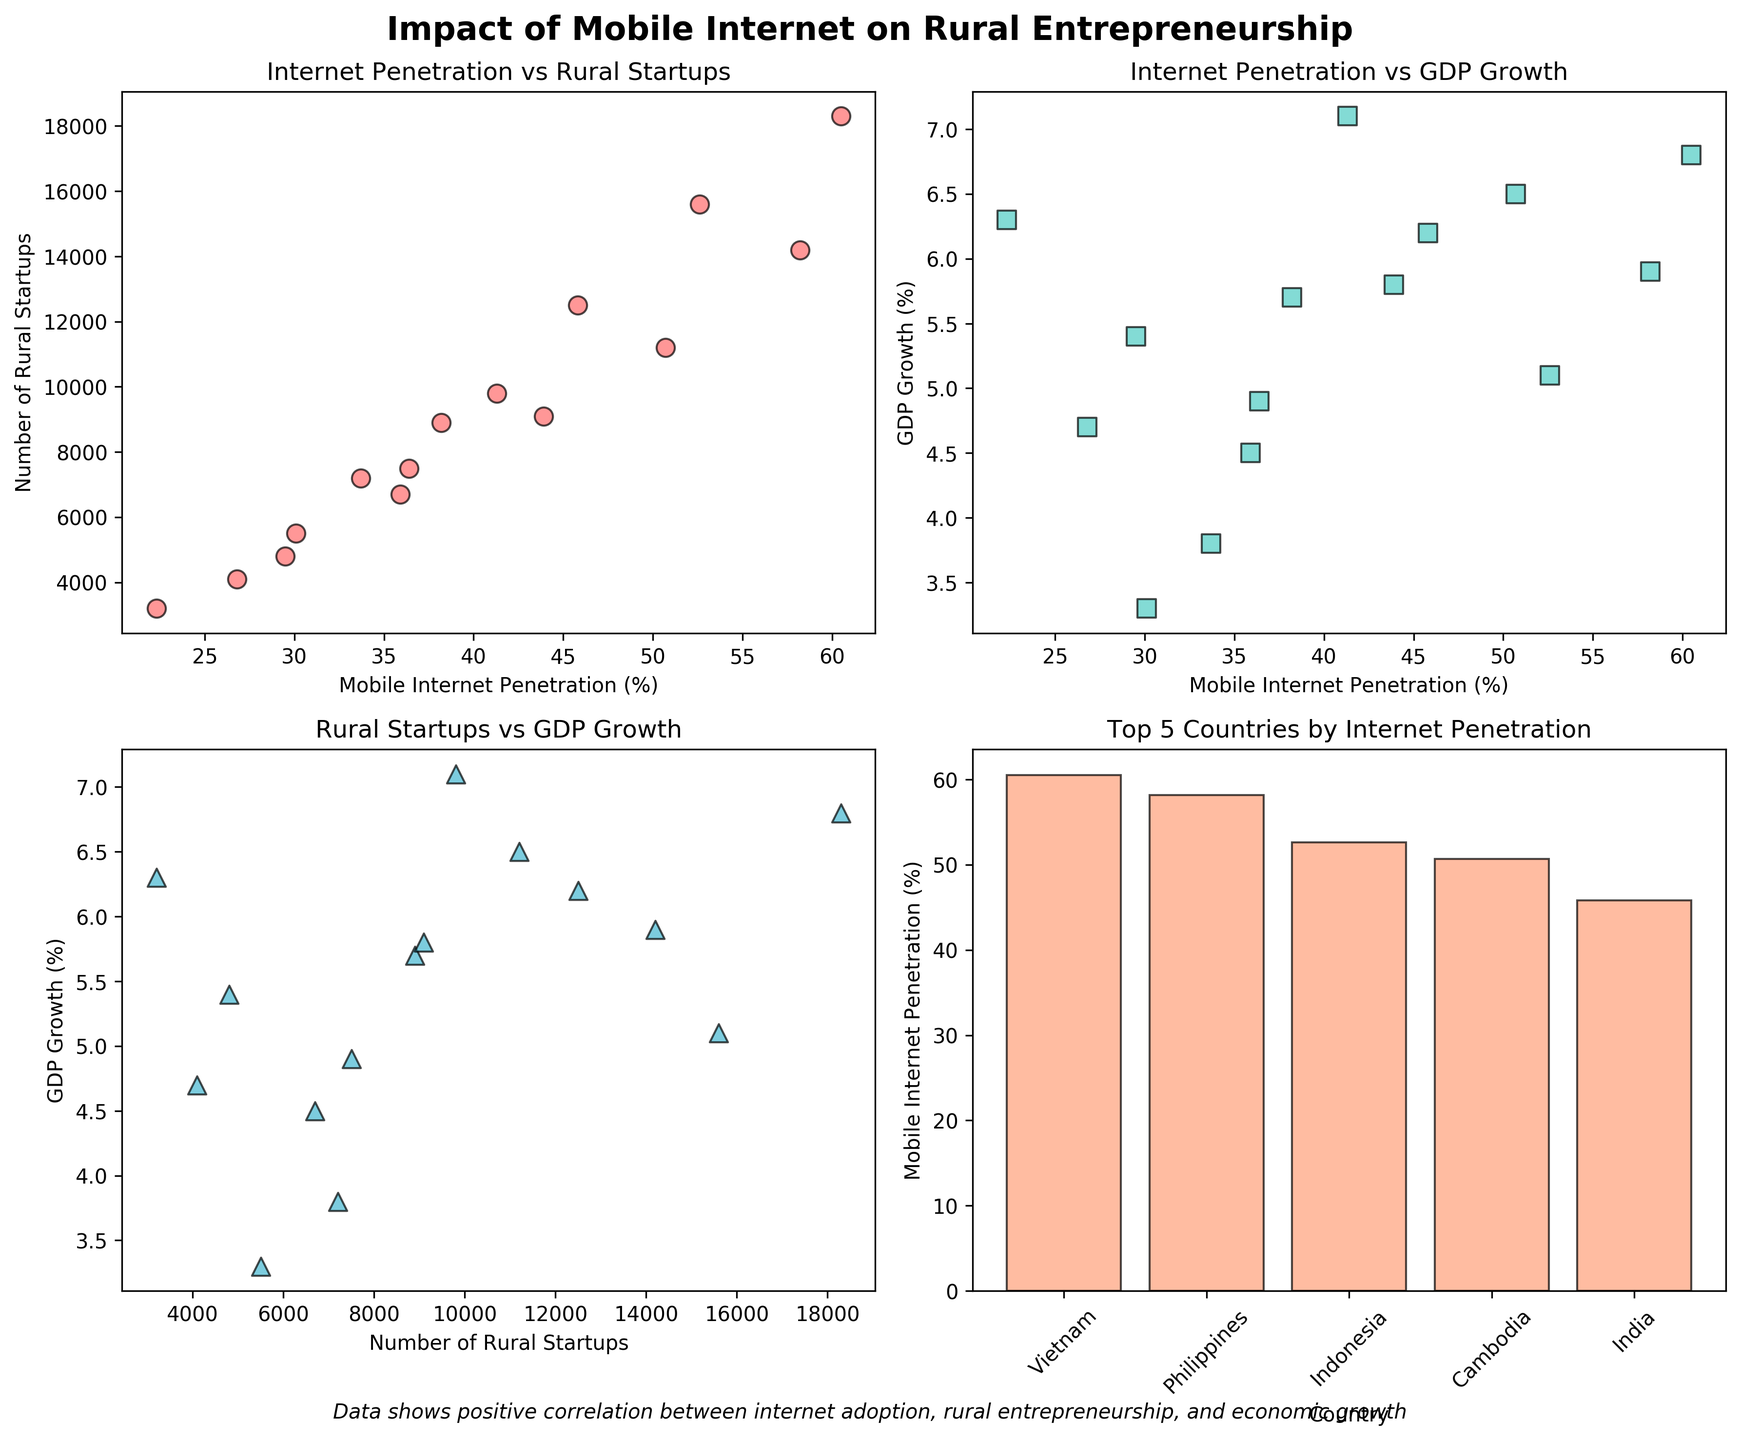How many scatter plots are in the figure? The figure contains 4 subplots, of which 3 are scatter plots and 1 is a bar plot. The scatter plots include: Internet Penetration vs Rural Startups (top left), Internet Penetration vs GDP Growth (top right), and Rural Startups vs GDP Growth (bottom left).
Answer: 3 What countries are represented in the bar plot? The bar plot shows the top 5 countries by Mobile Internet Penetration. By looking at the corresponding subplot (bottom right), the countries include Vietnam, Philippines, Indonesia, Cambodia, and India.
Answer: Vietnam, Philippines, Indonesia, Cambodia, India What is the relationship between Mobile Internet Penetration (%) and the number of Rural Startups? The scatter plot in the top left subplot illustrates this relationship. We observe that as Mobile Internet Penetration increases, the number of Rural Startups tends to also increase, indicating a positive correlation.
Answer: Positive correlation Which country has the lowest Mobile Internet Penetration (%)? By analyzing the data points in the scatter plots, the country with the lowest Mobile Internet Penetration is Ethiopia with a penetration rate of 22.3%.
Answer: Ethiopia What is the main observation from the scatter plot comparing Rural Startups and GDP Growth? In the bottom left subplot, we see that countries with a higher number of Rural Startups tend to have higher GDP Growth rates. This indicates a positive correlation between the number of Rural Startups and GDP Growth.
Answer: Positive correlation What is the Mobile Internet Penetration (%) in Bangladesh compared to Senegal? By referring to the scatter plot (top left) or bar plot (bottom right), we see that Bangladesh has a Mobile Internet Penetration of 41.3%, while Senegal has a penetration rate of 36.4%. Thus, Bangladesh has a higher Mobile Internet Penetration than Senegal.
Answer: Bangladesh: 41.3%, Senegal: 36.4% Which country has the highest GDP Growth (%) and how does it relate to its Mobile Internet Penetration (%)? Vietnam has the highest GDP Growth at 6.8%, and its Mobile Internet Penetration is 60.5%. This reflects a positive relationship where higher internet penetration correlates with higher GDP Growth.
Answer: Vietnam: 6.8%, 60.5% Calculate the average number of Rural Startups for countries with Mobile Internet Penetration above 50%. The countries with Mobile Internet Penetration above 50% are Indonesia (52.6%), Vietnam (60.5%), Philippines (58.2%), and Cambodia (50.7%). The number of Rural Startups in these countries are 15600, 18300, 14200, and 11200 respectively. The average number of Rural Startups is (15600 + 18300 + 14200 + 11200) / 4 = 14825.
Answer: 14825 